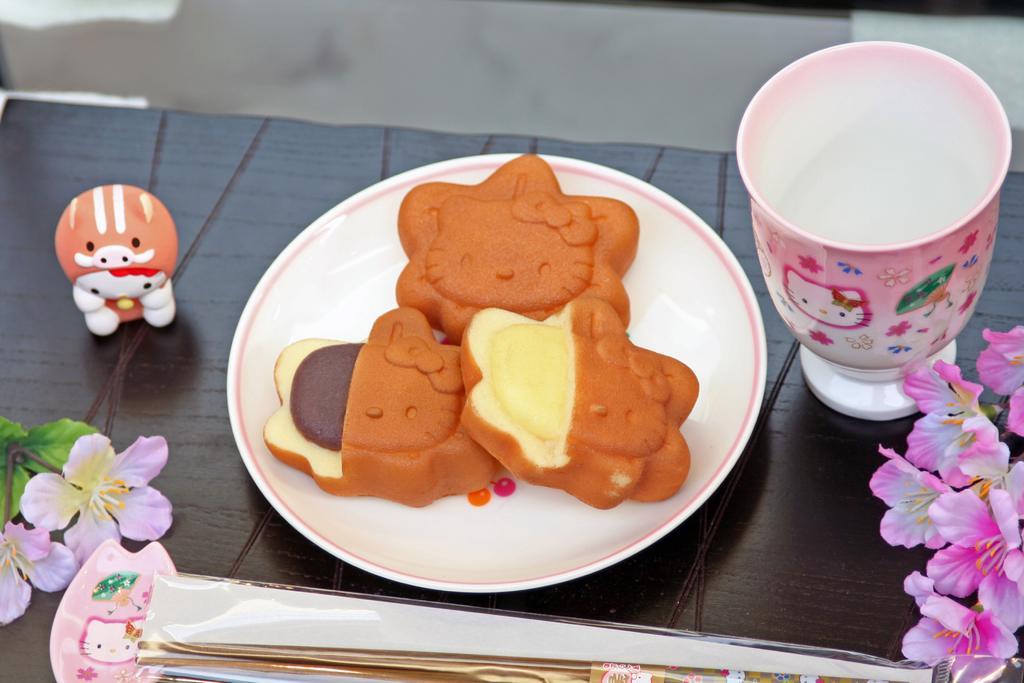Could you give a brief overview of what you see in this image? In this picture there are few eatables placed in a plate which is on the table and there is a cup few flowers and some other objects placed on it. 